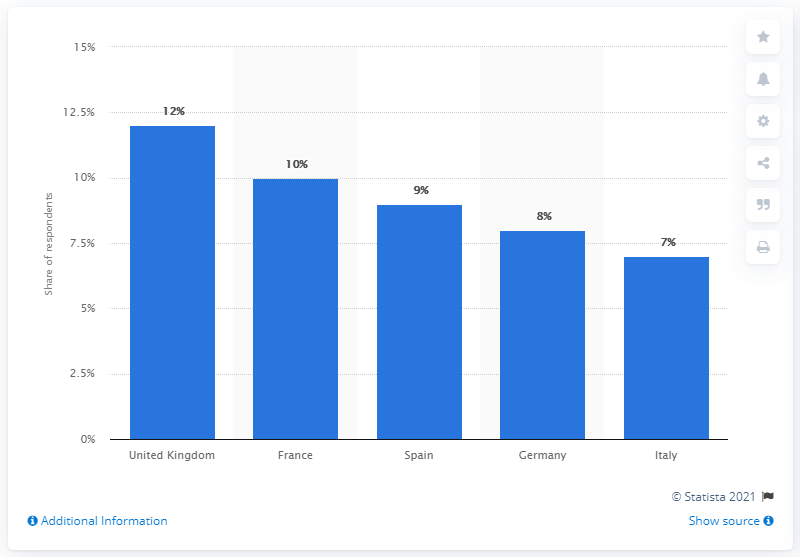Indicate a few pertinent items in this graphic. France had the largest share of respondents who now drink more alcohol than before the COVID-19 pandemic, according to a recent survey. 